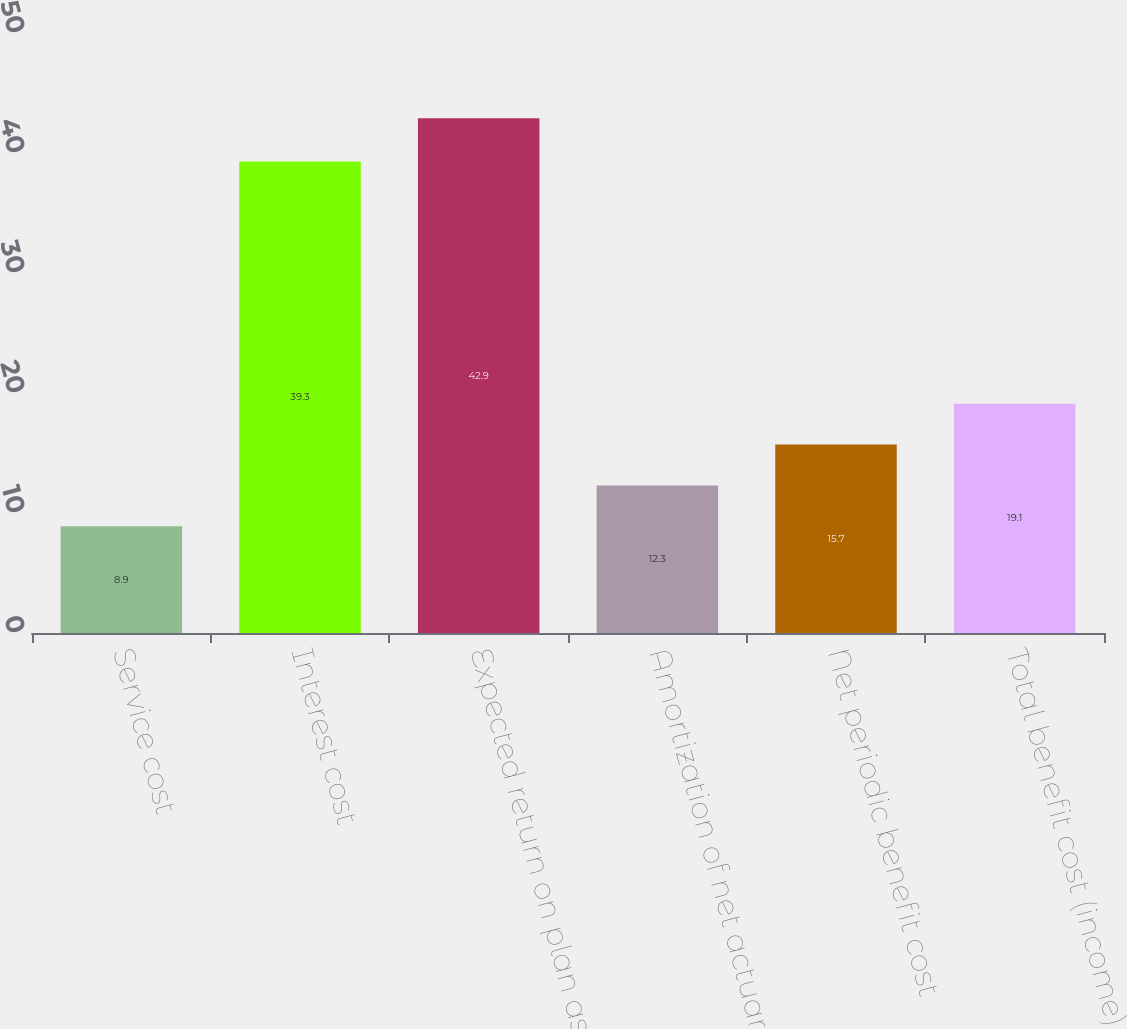Convert chart. <chart><loc_0><loc_0><loc_500><loc_500><bar_chart><fcel>Service cost<fcel>Interest cost<fcel>Expected return on plan assets<fcel>Amortization of net actuarial<fcel>Net periodic benefit cost<fcel>Total benefit cost (income)<nl><fcel>8.9<fcel>39.3<fcel>42.9<fcel>12.3<fcel>15.7<fcel>19.1<nl></chart> 